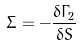<formula> <loc_0><loc_0><loc_500><loc_500>\Sigma = - \frac { \delta \Gamma _ { 2 } } { \delta S }</formula> 